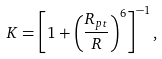Convert formula to latex. <formula><loc_0><loc_0><loc_500><loc_500>K = \left [ 1 + \left ( \frac { R _ { p t } } { R } \right ) ^ { 6 } \right ] ^ { - 1 } ,</formula> 